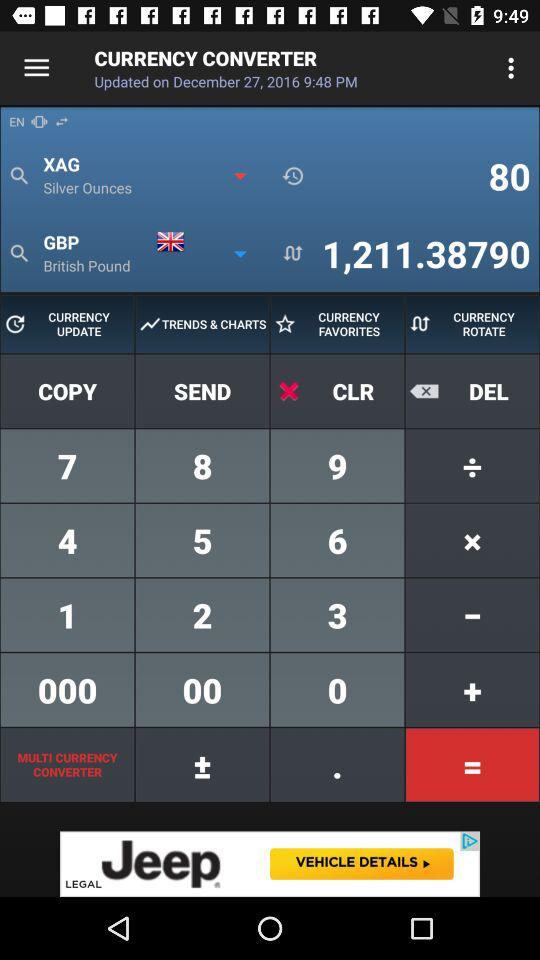At what time is the currency converter updated? The time is 9:48 pm. 